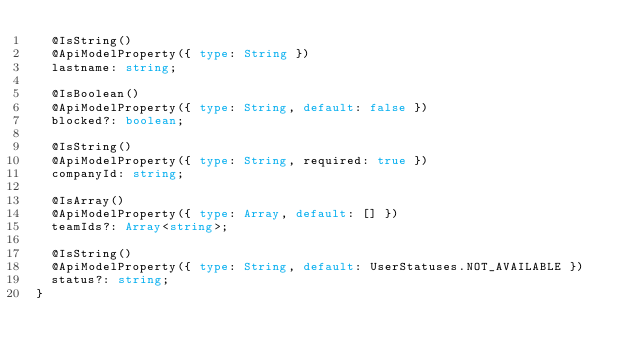Convert code to text. <code><loc_0><loc_0><loc_500><loc_500><_TypeScript_>  @IsString()
  @ApiModelProperty({ type: String })
  lastname: string;

  @IsBoolean()
  @ApiModelProperty({ type: String, default: false })
  blocked?: boolean;

  @IsString()
  @ApiModelProperty({ type: String, required: true })
  companyId: string;

  @IsArray()
  @ApiModelProperty({ type: Array, default: [] })
  teamIds?: Array<string>;

  @IsString()
  @ApiModelProperty({ type: String, default: UserStatuses.NOT_AVAILABLE })
  status?: string;
}
</code> 